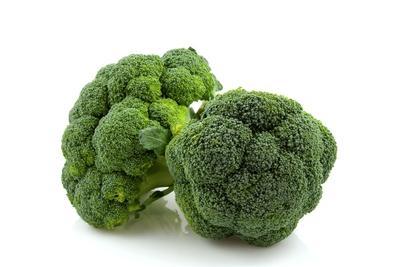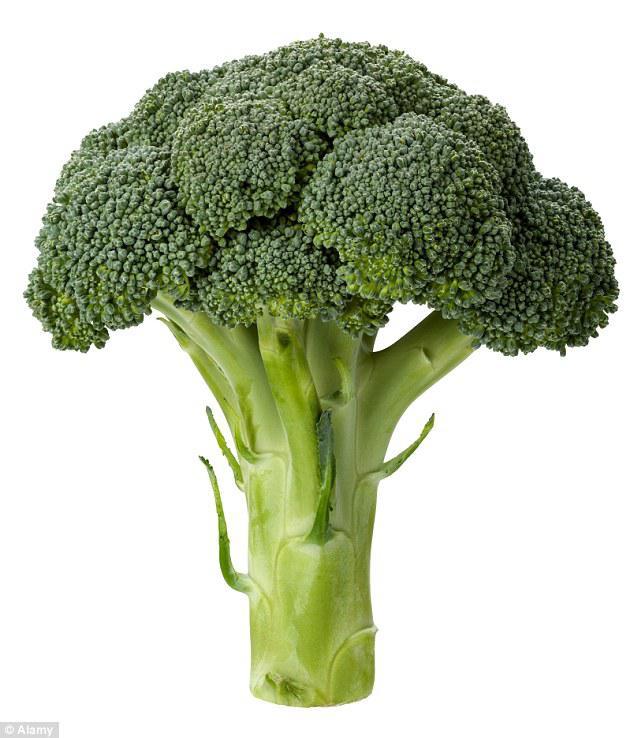The first image is the image on the left, the second image is the image on the right. Assess this claim about the two images: "there are 3 bunches of broccoli against a white background". Correct or not? Answer yes or no. Yes. 